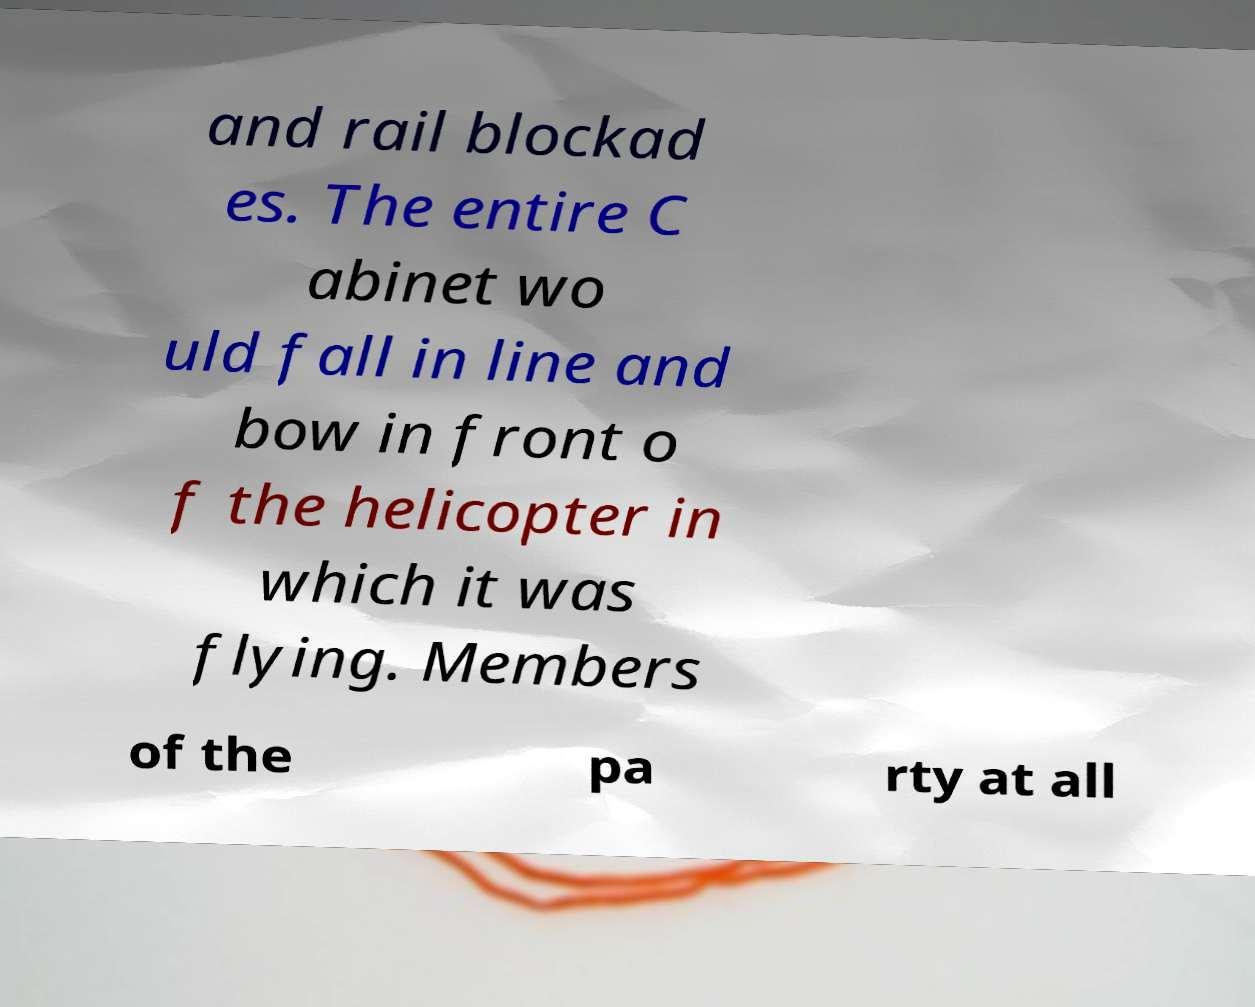What messages or text are displayed in this image? I need them in a readable, typed format. and rail blockad es. The entire C abinet wo uld fall in line and bow in front o f the helicopter in which it was flying. Members of the pa rty at all 